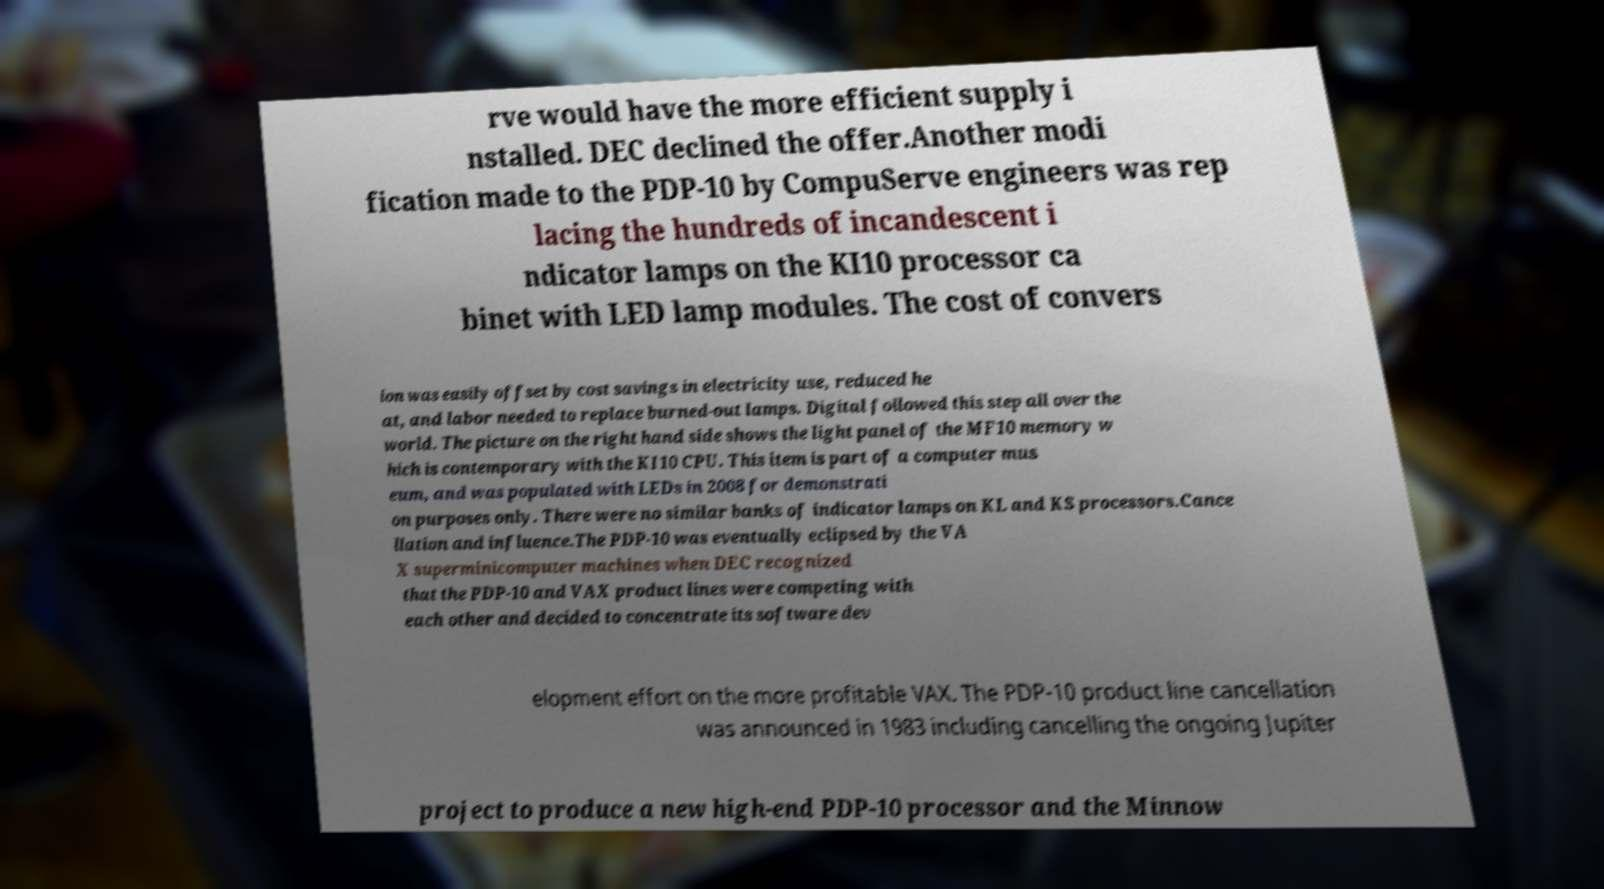Could you extract and type out the text from this image? rve would have the more efficient supply i nstalled. DEC declined the offer.Another modi fication made to the PDP-10 by CompuServe engineers was rep lacing the hundreds of incandescent i ndicator lamps on the KI10 processor ca binet with LED lamp modules. The cost of convers ion was easily offset by cost savings in electricity use, reduced he at, and labor needed to replace burned-out lamps. Digital followed this step all over the world. The picture on the right hand side shows the light panel of the MF10 memory w hich is contemporary with the KI10 CPU. This item is part of a computer mus eum, and was populated with LEDs in 2008 for demonstrati on purposes only. There were no similar banks of indicator lamps on KL and KS processors.Cance llation and influence.The PDP-10 was eventually eclipsed by the VA X superminicomputer machines when DEC recognized that the PDP-10 and VAX product lines were competing with each other and decided to concentrate its software dev elopment effort on the more profitable VAX. The PDP-10 product line cancellation was announced in 1983 including cancelling the ongoing Jupiter project to produce a new high-end PDP-10 processor and the Minnow 